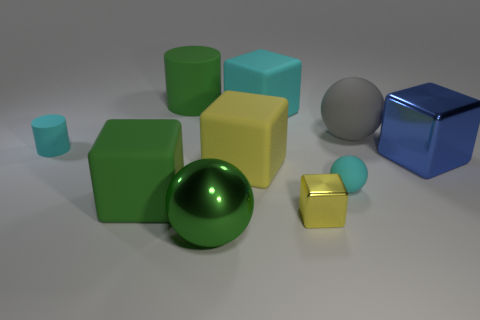How many large spheres are to the right of the gray matte ball?
Offer a very short reply. 0. The block that is the same color as the tiny metal thing is what size?
Offer a terse response. Large. Is there a large blue shiny thing that has the same shape as the big gray rubber thing?
Offer a very short reply. No. What color is the matte sphere that is the same size as the cyan cube?
Your response must be concise. Gray. Is the number of blue metallic blocks to the left of the big blue block less than the number of yellow metallic cubes that are to the left of the big cyan rubber block?
Give a very brief answer. No. There is a cyan thing that is in front of the cyan cylinder; does it have the same size as the green metallic object?
Offer a terse response. No. What is the shape of the tiny cyan object to the left of the large green matte cylinder?
Keep it short and to the point. Cylinder. Is the number of yellow objects greater than the number of large blue metallic things?
Your answer should be very brief. Yes. There is a block that is behind the gray rubber object; is it the same color as the large shiny sphere?
Give a very brief answer. No. What number of objects are either tiny things on the left side of the big cylinder or large matte things that are in front of the blue metal object?
Your answer should be very brief. 3. 